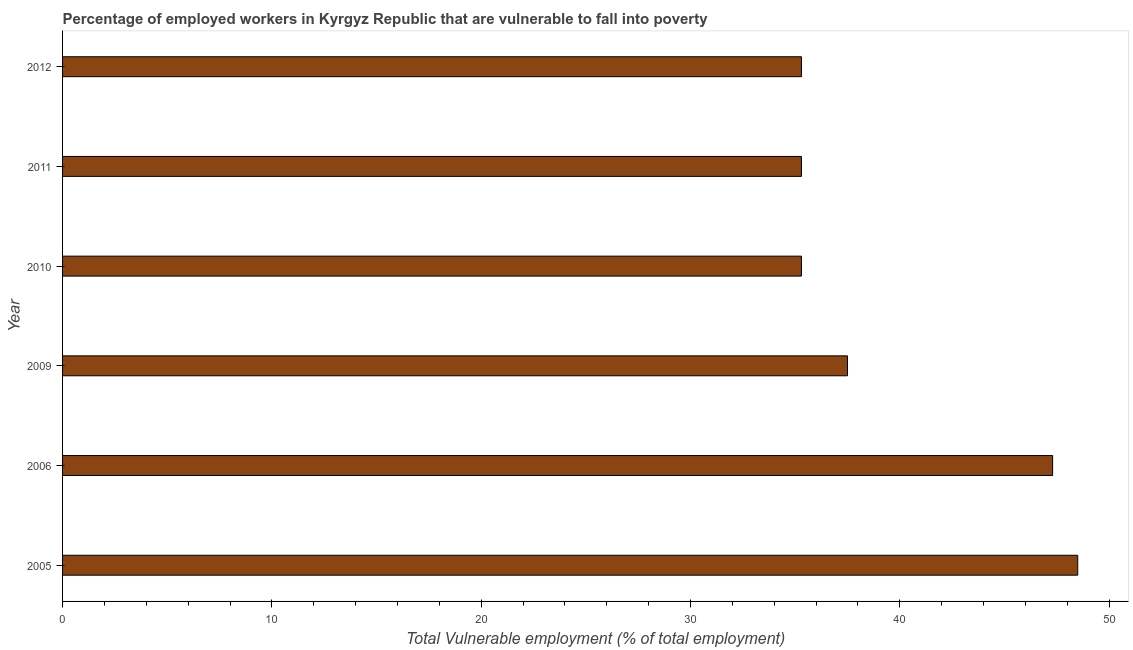Does the graph contain grids?
Your answer should be compact. No. What is the title of the graph?
Keep it short and to the point. Percentage of employed workers in Kyrgyz Republic that are vulnerable to fall into poverty. What is the label or title of the X-axis?
Offer a very short reply. Total Vulnerable employment (% of total employment). What is the label or title of the Y-axis?
Provide a short and direct response. Year. What is the total vulnerable employment in 2005?
Your answer should be compact. 48.5. Across all years, what is the maximum total vulnerable employment?
Your answer should be compact. 48.5. Across all years, what is the minimum total vulnerable employment?
Offer a terse response. 35.3. In which year was the total vulnerable employment maximum?
Ensure brevity in your answer.  2005. What is the sum of the total vulnerable employment?
Offer a very short reply. 239.2. What is the average total vulnerable employment per year?
Offer a terse response. 39.87. What is the median total vulnerable employment?
Your answer should be very brief. 36.4. What is the ratio of the total vulnerable employment in 2005 to that in 2012?
Give a very brief answer. 1.37. Is the total vulnerable employment in 2010 less than that in 2011?
Your response must be concise. No. Is the difference between the total vulnerable employment in 2005 and 2011 greater than the difference between any two years?
Offer a terse response. Yes. What is the difference between the highest and the second highest total vulnerable employment?
Provide a succinct answer. 1.2. Is the sum of the total vulnerable employment in 2005 and 2009 greater than the maximum total vulnerable employment across all years?
Your answer should be very brief. Yes. In how many years, is the total vulnerable employment greater than the average total vulnerable employment taken over all years?
Make the answer very short. 2. Are all the bars in the graph horizontal?
Your answer should be compact. Yes. What is the difference between two consecutive major ticks on the X-axis?
Your response must be concise. 10. What is the Total Vulnerable employment (% of total employment) in 2005?
Your response must be concise. 48.5. What is the Total Vulnerable employment (% of total employment) of 2006?
Provide a short and direct response. 47.3. What is the Total Vulnerable employment (% of total employment) of 2009?
Offer a very short reply. 37.5. What is the Total Vulnerable employment (% of total employment) of 2010?
Offer a terse response. 35.3. What is the Total Vulnerable employment (% of total employment) in 2011?
Provide a succinct answer. 35.3. What is the Total Vulnerable employment (% of total employment) in 2012?
Your answer should be very brief. 35.3. What is the difference between the Total Vulnerable employment (% of total employment) in 2005 and 2006?
Ensure brevity in your answer.  1.2. What is the difference between the Total Vulnerable employment (% of total employment) in 2005 and 2009?
Your answer should be compact. 11. What is the difference between the Total Vulnerable employment (% of total employment) in 2005 and 2011?
Your answer should be compact. 13.2. What is the difference between the Total Vulnerable employment (% of total employment) in 2005 and 2012?
Ensure brevity in your answer.  13.2. What is the difference between the Total Vulnerable employment (% of total employment) in 2006 and 2009?
Provide a short and direct response. 9.8. What is the difference between the Total Vulnerable employment (% of total employment) in 2006 and 2010?
Your answer should be very brief. 12. What is the difference between the Total Vulnerable employment (% of total employment) in 2009 and 2010?
Provide a succinct answer. 2.2. What is the difference between the Total Vulnerable employment (% of total employment) in 2009 and 2012?
Make the answer very short. 2.2. What is the difference between the Total Vulnerable employment (% of total employment) in 2011 and 2012?
Ensure brevity in your answer.  0. What is the ratio of the Total Vulnerable employment (% of total employment) in 2005 to that in 2009?
Your response must be concise. 1.29. What is the ratio of the Total Vulnerable employment (% of total employment) in 2005 to that in 2010?
Your answer should be very brief. 1.37. What is the ratio of the Total Vulnerable employment (% of total employment) in 2005 to that in 2011?
Keep it short and to the point. 1.37. What is the ratio of the Total Vulnerable employment (% of total employment) in 2005 to that in 2012?
Make the answer very short. 1.37. What is the ratio of the Total Vulnerable employment (% of total employment) in 2006 to that in 2009?
Your response must be concise. 1.26. What is the ratio of the Total Vulnerable employment (% of total employment) in 2006 to that in 2010?
Offer a terse response. 1.34. What is the ratio of the Total Vulnerable employment (% of total employment) in 2006 to that in 2011?
Keep it short and to the point. 1.34. What is the ratio of the Total Vulnerable employment (% of total employment) in 2006 to that in 2012?
Your answer should be compact. 1.34. What is the ratio of the Total Vulnerable employment (% of total employment) in 2009 to that in 2010?
Make the answer very short. 1.06. What is the ratio of the Total Vulnerable employment (% of total employment) in 2009 to that in 2011?
Keep it short and to the point. 1.06. What is the ratio of the Total Vulnerable employment (% of total employment) in 2009 to that in 2012?
Make the answer very short. 1.06. 